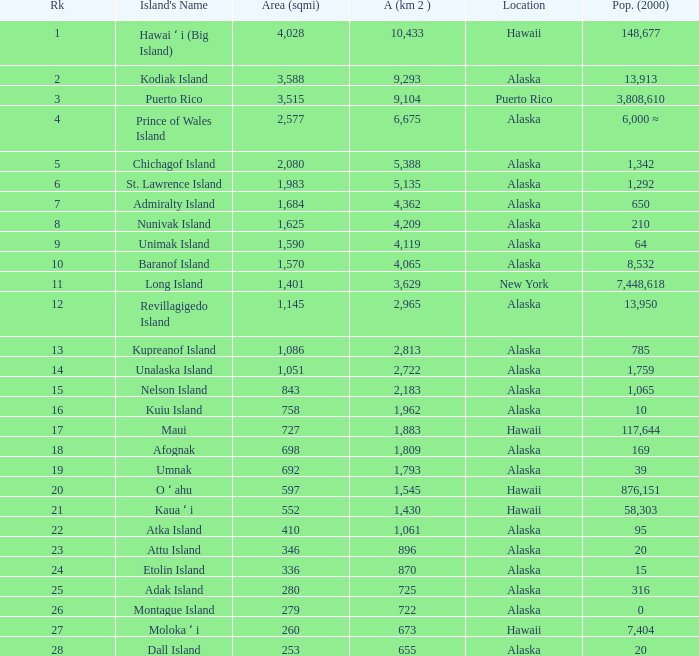What is the largest rank with 2,080 area? 5.0. 